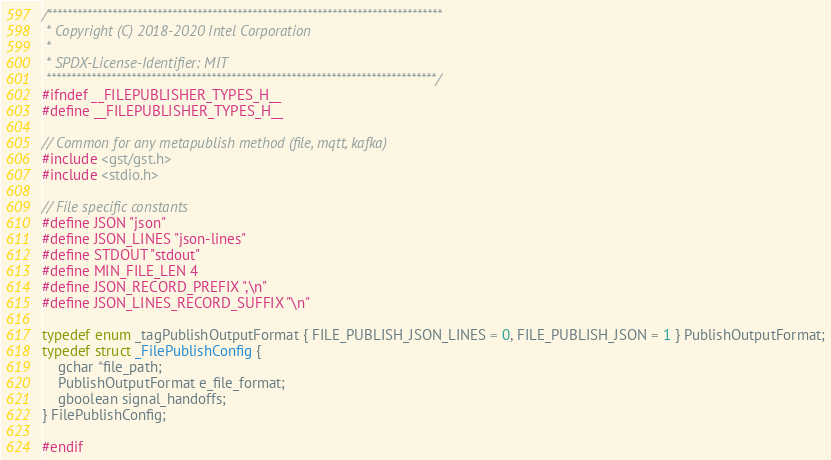Convert code to text. <code><loc_0><loc_0><loc_500><loc_500><_C_>/*******************************************************************************
 * Copyright (C) 2018-2020 Intel Corporation
 *
 * SPDX-License-Identifier: MIT
 ******************************************************************************/
#ifndef __FILEPUBLISHER_TYPES_H__
#define __FILEPUBLISHER_TYPES_H__

// Common for any metapublish method (file, mqtt, kafka)
#include <gst/gst.h>
#include <stdio.h>

// File specific constants
#define JSON "json"
#define JSON_LINES "json-lines"
#define STDOUT "stdout"
#define MIN_FILE_LEN 4
#define JSON_RECORD_PREFIX ",\n"
#define JSON_LINES_RECORD_SUFFIX "\n"

typedef enum _tagPublishOutputFormat { FILE_PUBLISH_JSON_LINES = 0, FILE_PUBLISH_JSON = 1 } PublishOutputFormat;
typedef struct _FilePublishConfig {
    gchar *file_path;
    PublishOutputFormat e_file_format;
    gboolean signal_handoffs;
} FilePublishConfig;

#endif
</code> 